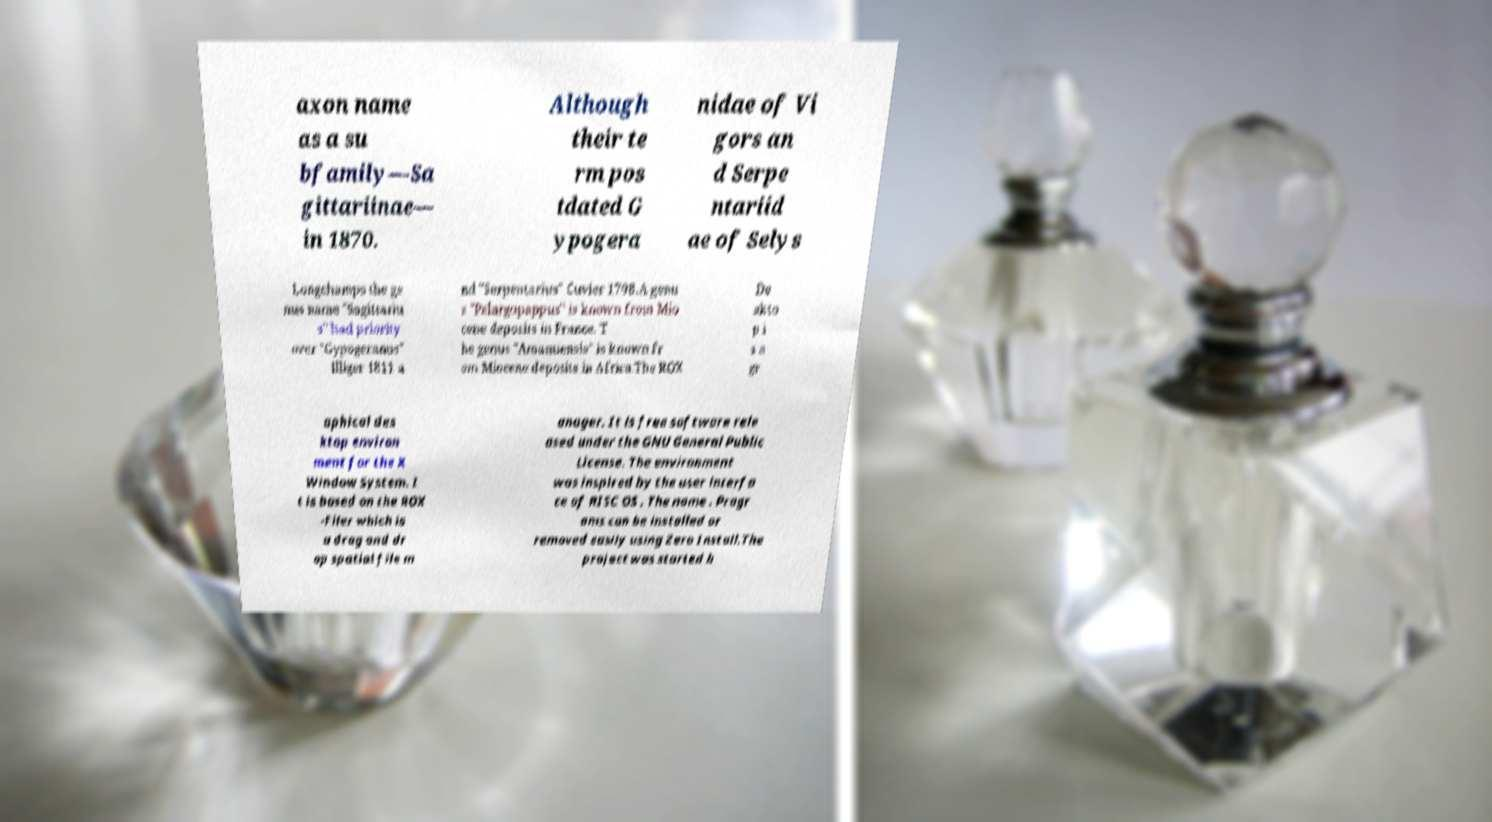Could you assist in decoding the text presented in this image and type it out clearly? axon name as a su bfamily—Sa gittariinae— in 1870. Although their te rm pos tdated G ypogera nidae of Vi gors an d Serpe ntariid ae of Selys Longchamps the ge nus name "Sagittariu s" had priority over "Gypogeranus" Illiger 1811 a nd "Serpentarius" Cuvier 1798.A genu s "Pelargopappus" is known from Mio cene deposits in France. T he genus "Amanuensis" is known fr om Miocene deposits in Africa.The ROX De skto p i s a gr aphical des ktop environ ment for the X Window System. I t is based on the ROX -Filer which is a drag and dr op spatial file m anager. It is free software rele ased under the GNU General Public License. The environment was inspired by the user interfa ce of RISC OS . The name . Progr ams can be installed or removed easily using Zero Install.The project was started b 